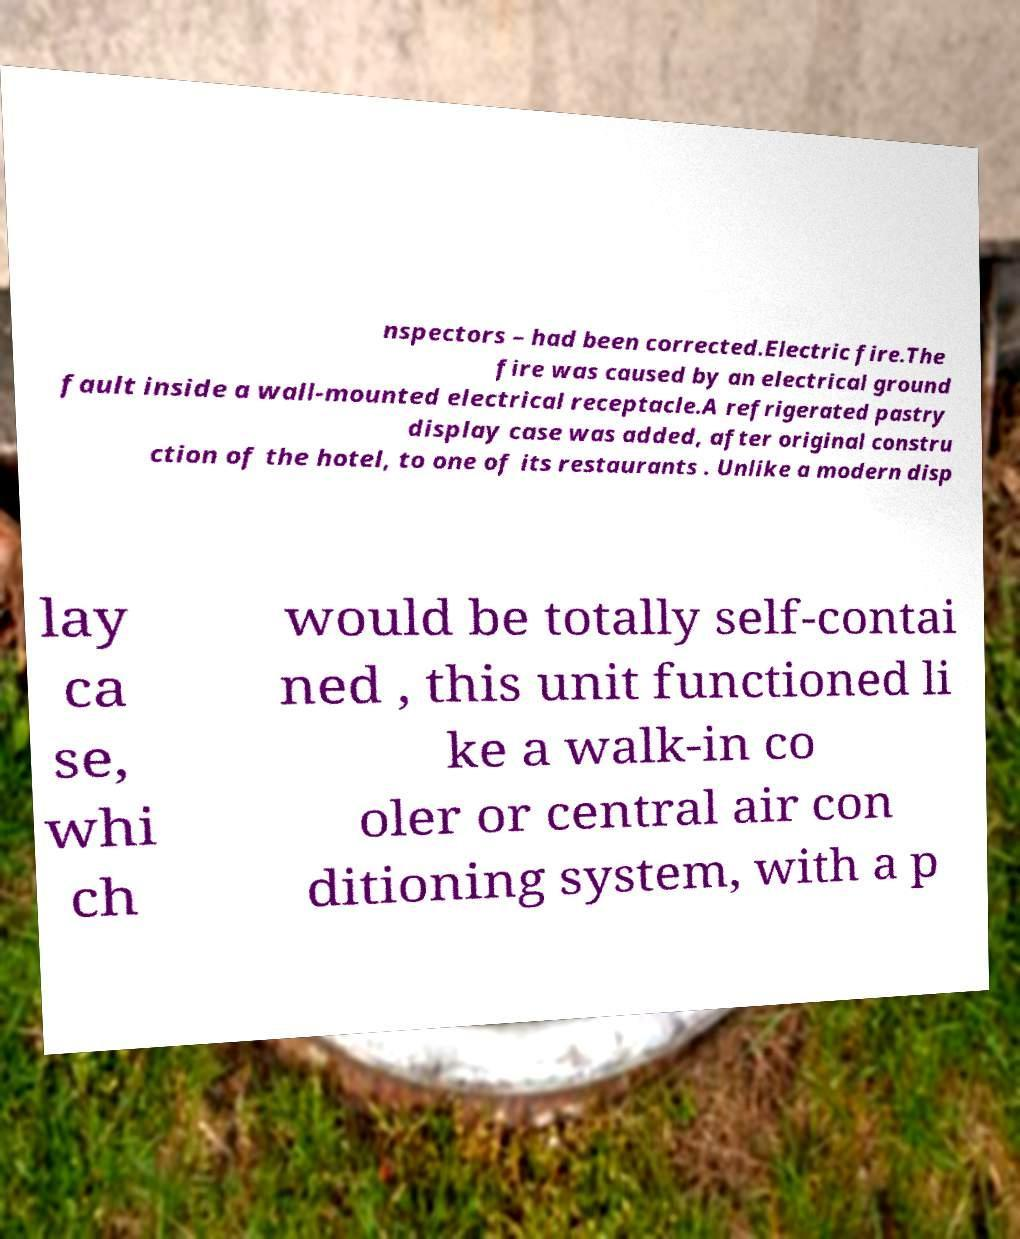Could you assist in decoding the text presented in this image and type it out clearly? nspectors – had been corrected.Electric fire.The fire was caused by an electrical ground fault inside a wall-mounted electrical receptacle.A refrigerated pastry display case was added, after original constru ction of the hotel, to one of its restaurants . Unlike a modern disp lay ca se, whi ch would be totally self-contai ned , this unit functioned li ke a walk-in co oler or central air con ditioning system, with a p 